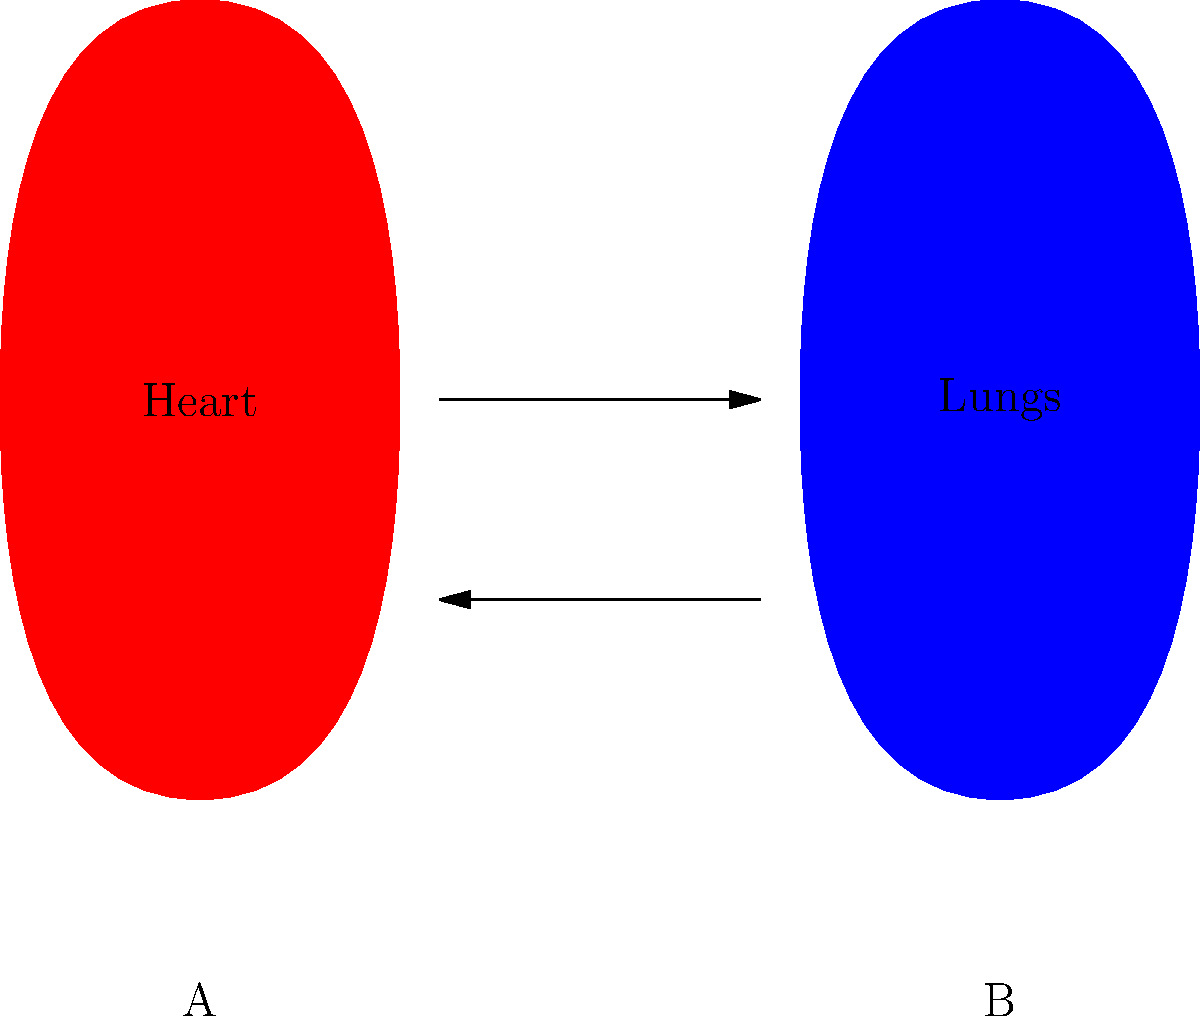In the diagram above, which organ system (A or B) is primarily responsible for gas exchange, and how does it interact with the other system shown? To answer this question, let's analyze the diagram and the interaction between the two organ systems:

1. System A (left side):
   - Represented by a red, heart-shaped structure
   - Label indicates it's the "Heart"
   - This represents the Circulatory System

2. System B (right side):
   - Represented by a blue, lung-shaped structure
   - Label indicates these are the "Lungs"
   - This represents the Respiratory System

3. Interaction between systems:
   - Arrows show a two-way interaction between the systems

4. Gas exchange:
   - The primary function of gas exchange occurs in the lungs (System B)
   - Oxygen is taken in and carbon dioxide is expelled during respiration

5. System interaction for gas exchange:
   - The circulatory system (A) pumps deoxygenated blood to the lungs (B)
   - In the lungs, oxygen is picked up by the blood, and carbon dioxide is released
   - The oxygenated blood then returns to the heart to be pumped throughout the body

Therefore, System B (Respiratory System) is primarily responsible for gas exchange. It interacts with System A (Circulatory System) by receiving deoxygenated blood, facilitating gas exchange, and sending oxygenated blood back to the heart for distribution.
Answer: System B (Respiratory System); it exchanges gases with the Circulatory System (A). 